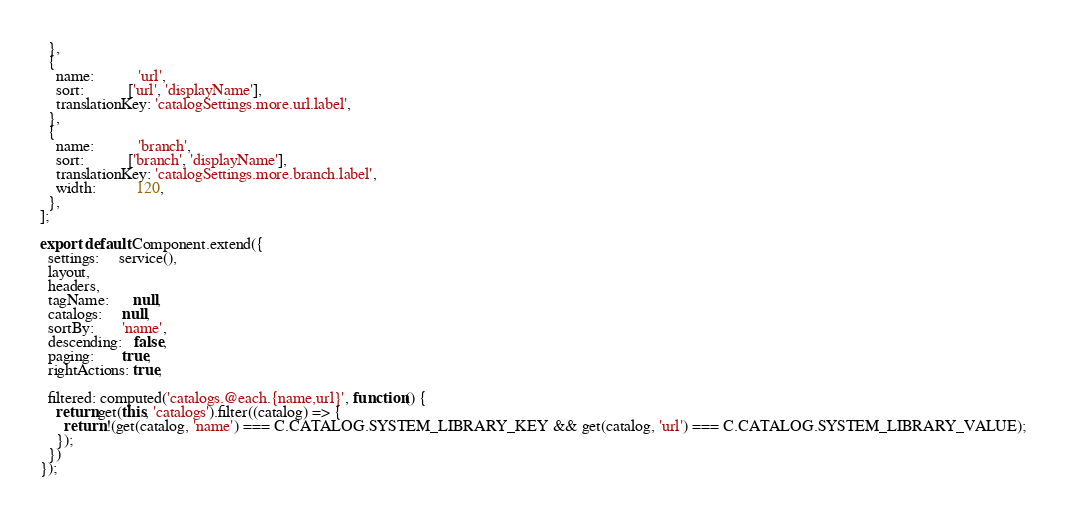<code> <loc_0><loc_0><loc_500><loc_500><_JavaScript_>  },
  {
    name:           'url',
    sort:           ['url', 'displayName'],
    translationKey: 'catalogSettings.more.url.label',
  },
  {
    name:           'branch',
    sort:           ['branch', 'displayName'],
    translationKey: 'catalogSettings.more.branch.label',
    width:          120,
  },
];

export default Component.extend({
  settings:     service(),
  layout,
  headers,
  tagName:      null,
  catalogs:     null,
  sortBy:       'name',
  descending:   false,
  paging:       true,
  rightActions: true,

  filtered: computed('catalogs.@each.{name,url}', function() {
    return get(this, 'catalogs').filter((catalog) => {
      return !(get(catalog, 'name') === C.CATALOG.SYSTEM_LIBRARY_KEY && get(catalog, 'url') === C.CATALOG.SYSTEM_LIBRARY_VALUE);
    });
  })
});
</code> 